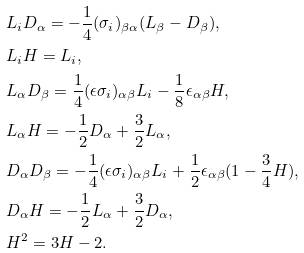<formula> <loc_0><loc_0><loc_500><loc_500>& L _ { i } D _ { \alpha } = - \frac { 1 } { 4 } ( \sigma _ { i } ) _ { \beta \alpha } ( L _ { \beta } - D _ { \beta } ) , \\ & L _ { i } H = L _ { i } , \\ & L _ { \alpha } D _ { \beta } = \frac { 1 } { 4 } ( \epsilon \sigma _ { i } ) _ { \alpha \beta } L _ { i } - \frac { 1 } { 8 } \epsilon _ { \alpha \beta } H , \\ & L _ { \alpha } H = - \frac { 1 } { 2 } D _ { \alpha } + \frac { 3 } { 2 } L _ { \alpha } , \\ & D _ { \alpha } D _ { \beta } = - \frac { 1 } { 4 } ( \epsilon \sigma _ { i } ) _ { \alpha \beta } L _ { i } + \frac { 1 } { 2 } \epsilon _ { \alpha \beta } ( 1 - \frac { 3 } { 4 } H ) , \\ & D _ { \alpha } H = - \frac { 1 } { 2 } L _ { \alpha } + \frac { 3 } { 2 } D _ { \alpha } , \\ & H ^ { 2 } = 3 H - 2 .</formula> 